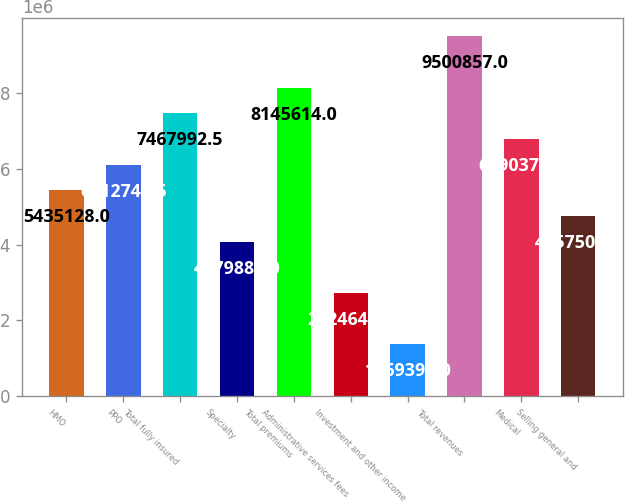Convert chart to OTSL. <chart><loc_0><loc_0><loc_500><loc_500><bar_chart><fcel>HMO<fcel>PPO<fcel>Total fully insured<fcel>Specialty<fcel>Total premiums<fcel>Administrative services fees<fcel>Investment and other income<fcel>Total revenues<fcel>Medical<fcel>Selling general and<nl><fcel>5.43513e+06<fcel>6.11275e+06<fcel>7.46799e+06<fcel>4.07988e+06<fcel>8.14561e+06<fcel>2.72464e+06<fcel>1.3694e+06<fcel>9.50086e+06<fcel>6.79037e+06<fcel>4.75751e+06<nl></chart> 